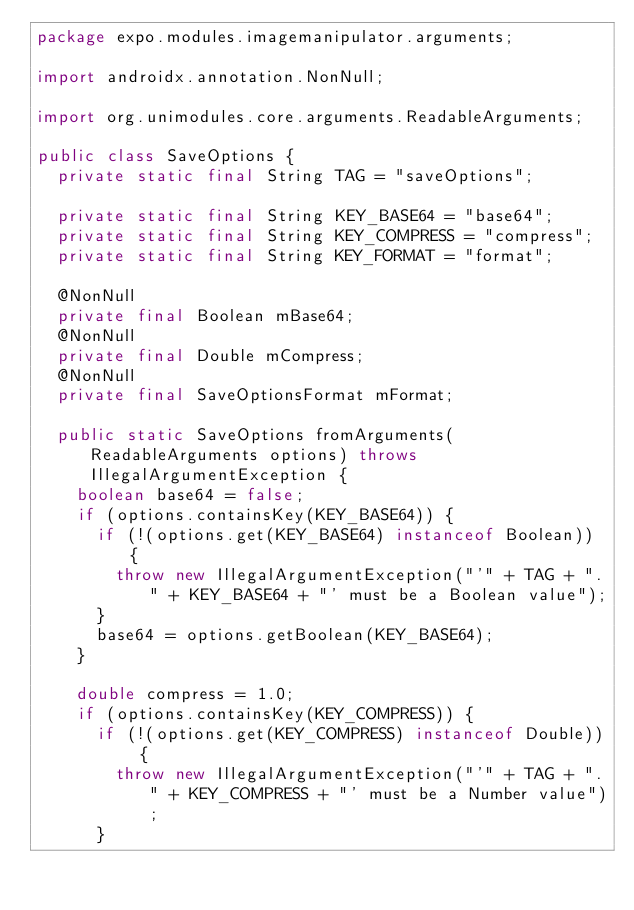Convert code to text. <code><loc_0><loc_0><loc_500><loc_500><_Java_>package expo.modules.imagemanipulator.arguments;

import androidx.annotation.NonNull;

import org.unimodules.core.arguments.ReadableArguments;

public class SaveOptions {
  private static final String TAG = "saveOptions";

  private static final String KEY_BASE64 = "base64";
  private static final String KEY_COMPRESS = "compress";
  private static final String KEY_FORMAT = "format";

  @NonNull
  private final Boolean mBase64;
  @NonNull
  private final Double mCompress;
  @NonNull
  private final SaveOptionsFormat mFormat;

  public static SaveOptions fromArguments(ReadableArguments options) throws IllegalArgumentException {
    boolean base64 = false;
    if (options.containsKey(KEY_BASE64)) {
      if (!(options.get(KEY_BASE64) instanceof Boolean)) {
        throw new IllegalArgumentException("'" + TAG + "." + KEY_BASE64 + "' must be a Boolean value");
      }
      base64 = options.getBoolean(KEY_BASE64);
    }

    double compress = 1.0;
    if (options.containsKey(KEY_COMPRESS)) {
      if (!(options.get(KEY_COMPRESS) instanceof Double)) {
        throw new IllegalArgumentException("'" + TAG + "." + KEY_COMPRESS + "' must be a Number value");
      }</code> 